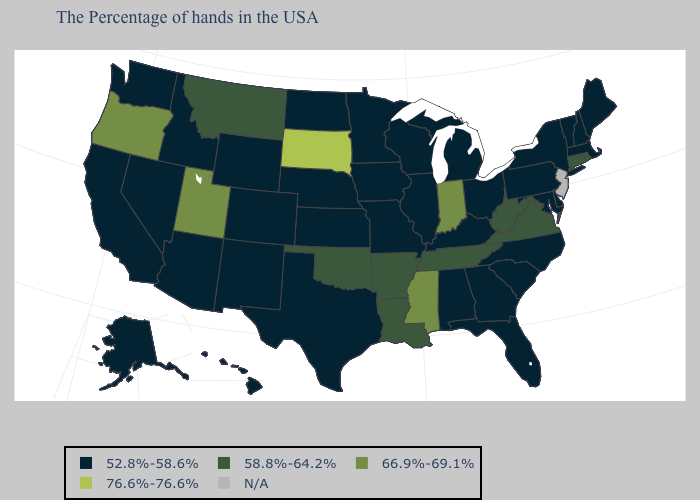What is the value of Louisiana?
Write a very short answer. 58.8%-64.2%. Name the states that have a value in the range 58.8%-64.2%?
Short answer required. Rhode Island, Connecticut, Virginia, West Virginia, Tennessee, Louisiana, Arkansas, Oklahoma, Montana. How many symbols are there in the legend?
Give a very brief answer. 5. Name the states that have a value in the range 76.6%-76.6%?
Answer briefly. South Dakota. What is the lowest value in the USA?
Keep it brief. 52.8%-58.6%. Does Delaware have the lowest value in the South?
Answer briefly. Yes. Name the states that have a value in the range 66.9%-69.1%?
Write a very short answer. Indiana, Mississippi, Utah, Oregon. What is the value of Wyoming?
Quick response, please. 52.8%-58.6%. Name the states that have a value in the range 76.6%-76.6%?
Be succinct. South Dakota. What is the lowest value in states that border Michigan?
Be succinct. 52.8%-58.6%. What is the lowest value in the West?
Be succinct. 52.8%-58.6%. Which states have the highest value in the USA?
Keep it brief. South Dakota. Which states hav the highest value in the MidWest?
Write a very short answer. South Dakota. 